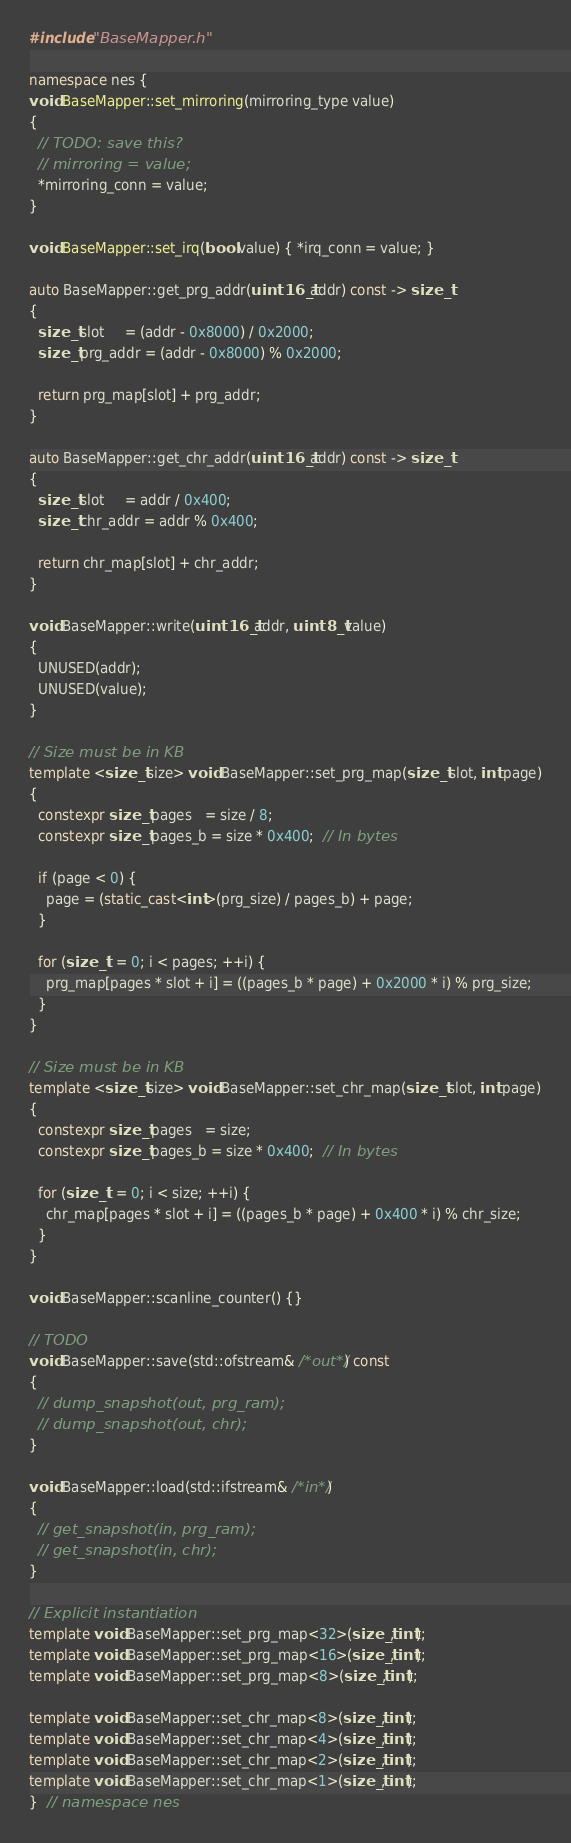<code> <loc_0><loc_0><loc_500><loc_500><_C++_>#include "BaseMapper.h"

namespace nes {
void BaseMapper::set_mirroring(mirroring_type value)
{
  // TODO: save this?
  // mirroring = value;
  *mirroring_conn = value;
}

void BaseMapper::set_irq(bool value) { *irq_conn = value; }

auto BaseMapper::get_prg_addr(uint16_t addr) const -> size_t
{
  size_t slot     = (addr - 0x8000) / 0x2000;
  size_t prg_addr = (addr - 0x8000) % 0x2000;

  return prg_map[slot] + prg_addr;
}

auto BaseMapper::get_chr_addr(uint16_t addr) const -> size_t
{
  size_t slot     = addr / 0x400;
  size_t chr_addr = addr % 0x400;

  return chr_map[slot] + chr_addr;
}

void BaseMapper::write(uint16_t addr, uint8_t value)
{
  UNUSED(addr);
  UNUSED(value);
}

// Size must be in KB
template <size_t size> void BaseMapper::set_prg_map(size_t slot, int page)
{
  constexpr size_t pages   = size / 8;
  constexpr size_t pages_b = size * 0x400;  // In bytes

  if (page < 0) {
    page = (static_cast<int>(prg_size) / pages_b) + page;
  }

  for (size_t i = 0; i < pages; ++i) {
    prg_map[pages * slot + i] = ((pages_b * page) + 0x2000 * i) % prg_size;
  }
}

// Size must be in KB
template <size_t size> void BaseMapper::set_chr_map(size_t slot, int page)
{
  constexpr size_t pages   = size;
  constexpr size_t pages_b = size * 0x400;  // In bytes

  for (size_t i = 0; i < size; ++i) {
    chr_map[pages * slot + i] = ((pages_b * page) + 0x400 * i) % chr_size;
  }
}

void BaseMapper::scanline_counter() {}

// TODO
void BaseMapper::save(std::ofstream& /*out*/) const
{
  // dump_snapshot(out, prg_ram);
  // dump_snapshot(out, chr);
}

void BaseMapper::load(std::ifstream& /*in*/)
{
  // get_snapshot(in, prg_ram);
  // get_snapshot(in, chr);
}

// Explicit instantiation
template void BaseMapper::set_prg_map<32>(size_t, int);
template void BaseMapper::set_prg_map<16>(size_t, int);
template void BaseMapper::set_prg_map<8>(size_t, int);

template void BaseMapper::set_chr_map<8>(size_t, int);
template void BaseMapper::set_chr_map<4>(size_t, int);
template void BaseMapper::set_chr_map<2>(size_t, int);
template void BaseMapper::set_chr_map<1>(size_t, int);
}  // namespace nes
</code> 